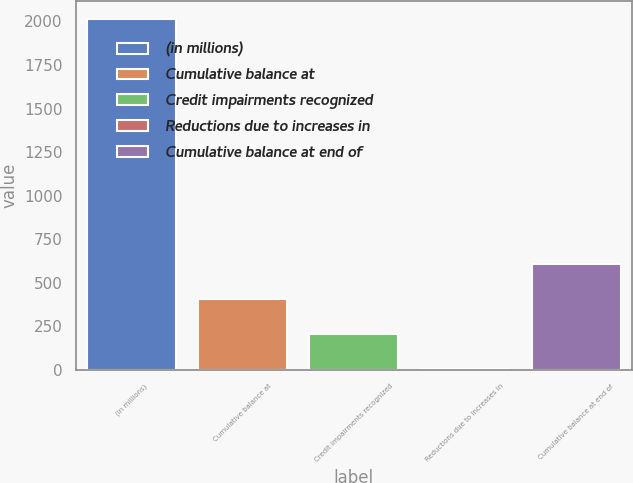Convert chart. <chart><loc_0><loc_0><loc_500><loc_500><bar_chart><fcel>(in millions)<fcel>Cumulative balance at<fcel>Credit impairments recognized<fcel>Reductions due to increases in<fcel>Cumulative balance at end of<nl><fcel>2016<fcel>405.6<fcel>204.3<fcel>3<fcel>606.9<nl></chart> 